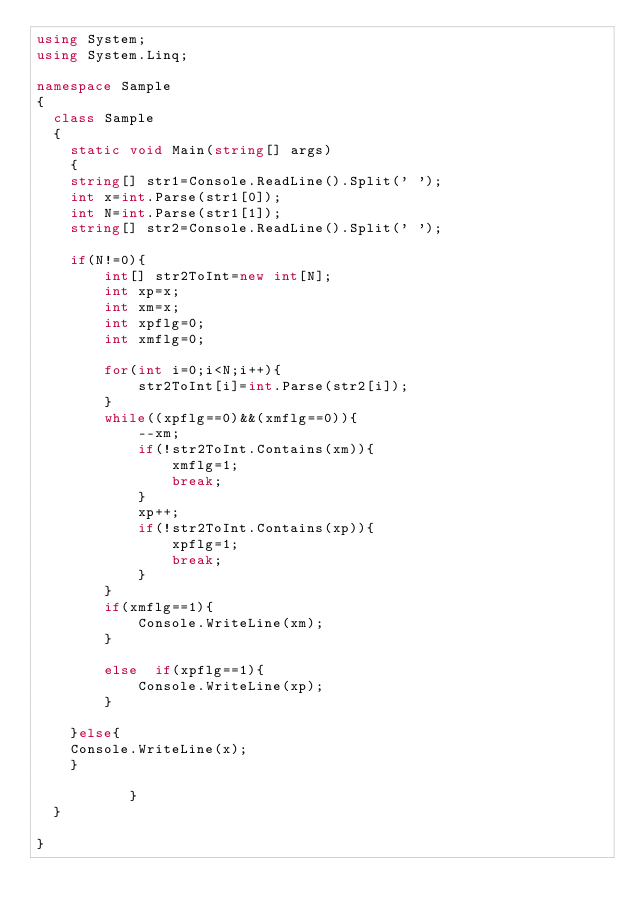<code> <loc_0><loc_0><loc_500><loc_500><_C#_>using System;
using System.Linq;

namespace Sample
{
  class Sample
  {
    static void Main(string[] args)
    {
    string[] str1=Console.ReadLine().Split(' ');
    int x=int.Parse(str1[0]);
    int N=int.Parse(str1[1]);
    string[] str2=Console.ReadLine().Split(' ');
    
    if(N!=0){
        int[] str2ToInt=new int[N];
        int xp=x;
        int xm=x;
        int xpflg=0;
        int xmflg=0;
        
        for(int i=0;i<N;i++){
            str2ToInt[i]=int.Parse(str2[i]);
        }
        while((xpflg==0)&&(xmflg==0)){
            --xm;
            if(!str2ToInt.Contains(xm)){
                xmflg=1;
                break;
            }
            xp++;
            if(!str2ToInt.Contains(xp)){
                xpflg=1;
                break;
            }
        }
        if(xmflg==1){
            Console.WriteLine(xm);
        }
    
        else  if(xpflg==1){
            Console.WriteLine(xp);
        }
        
    }else{
    Console.WriteLine(x);
    }

           }
  }

}</code> 